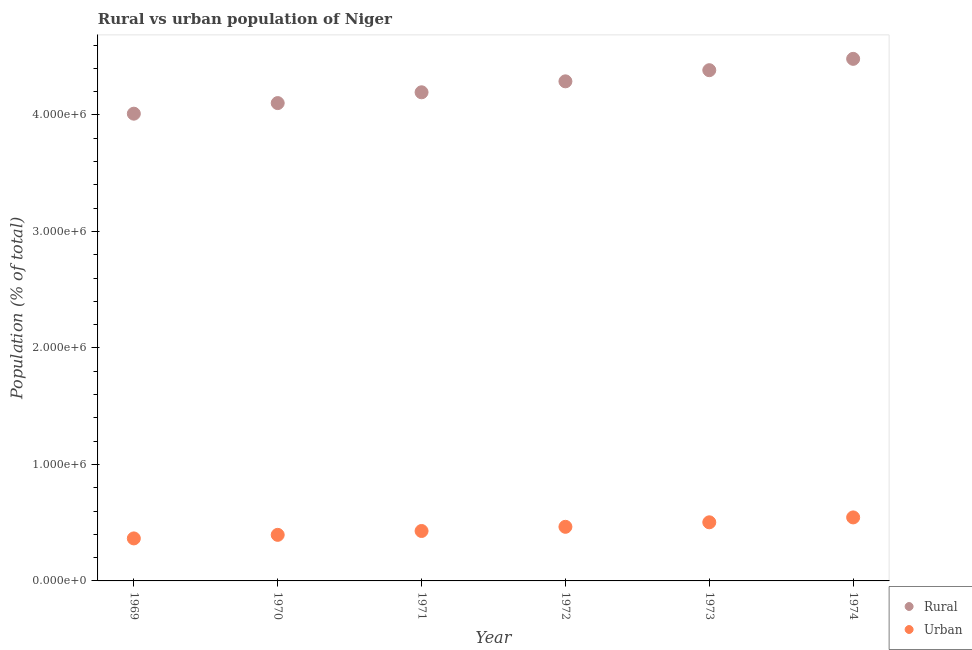What is the rural population density in 1972?
Your response must be concise. 4.29e+06. Across all years, what is the maximum urban population density?
Your response must be concise. 5.45e+05. Across all years, what is the minimum rural population density?
Offer a very short reply. 4.01e+06. In which year was the urban population density maximum?
Provide a succinct answer. 1974. In which year was the urban population density minimum?
Keep it short and to the point. 1969. What is the total rural population density in the graph?
Offer a very short reply. 2.55e+07. What is the difference between the rural population density in 1970 and that in 1972?
Provide a short and direct response. -1.87e+05. What is the difference between the urban population density in 1973 and the rural population density in 1971?
Ensure brevity in your answer.  -3.69e+06. What is the average urban population density per year?
Your response must be concise. 4.50e+05. In the year 1972, what is the difference between the urban population density and rural population density?
Ensure brevity in your answer.  -3.82e+06. What is the ratio of the rural population density in 1971 to that in 1973?
Offer a terse response. 0.96. What is the difference between the highest and the second highest rural population density?
Offer a very short reply. 9.73e+04. What is the difference between the highest and the lowest rural population density?
Give a very brief answer. 4.71e+05. In how many years, is the rural population density greater than the average rural population density taken over all years?
Your answer should be compact. 3. Is the sum of the rural population density in 1969 and 1974 greater than the maximum urban population density across all years?
Provide a short and direct response. Yes. Is the rural population density strictly greater than the urban population density over the years?
Give a very brief answer. Yes. Is the rural population density strictly less than the urban population density over the years?
Ensure brevity in your answer.  No. How many dotlines are there?
Your answer should be compact. 2. Does the graph contain any zero values?
Your answer should be very brief. No. Does the graph contain grids?
Your response must be concise. No. Where does the legend appear in the graph?
Make the answer very short. Bottom right. How many legend labels are there?
Offer a terse response. 2. How are the legend labels stacked?
Offer a terse response. Vertical. What is the title of the graph?
Your answer should be very brief. Rural vs urban population of Niger. Does "Foreign liabilities" appear as one of the legend labels in the graph?
Your response must be concise. No. What is the label or title of the Y-axis?
Keep it short and to the point. Population (% of total). What is the Population (% of total) in Rural in 1969?
Offer a terse response. 4.01e+06. What is the Population (% of total) in Urban in 1969?
Your answer should be very brief. 3.65e+05. What is the Population (% of total) in Rural in 1970?
Your response must be concise. 4.10e+06. What is the Population (% of total) of Urban in 1970?
Your answer should be very brief. 3.95e+05. What is the Population (% of total) of Rural in 1971?
Make the answer very short. 4.19e+06. What is the Population (% of total) in Urban in 1971?
Offer a very short reply. 4.29e+05. What is the Population (% of total) in Rural in 1972?
Your response must be concise. 4.29e+06. What is the Population (% of total) in Urban in 1972?
Your answer should be very brief. 4.64e+05. What is the Population (% of total) of Rural in 1973?
Make the answer very short. 4.38e+06. What is the Population (% of total) of Urban in 1973?
Make the answer very short. 5.03e+05. What is the Population (% of total) in Rural in 1974?
Provide a short and direct response. 4.48e+06. What is the Population (% of total) of Urban in 1974?
Offer a terse response. 5.45e+05. Across all years, what is the maximum Population (% of total) of Rural?
Provide a succinct answer. 4.48e+06. Across all years, what is the maximum Population (% of total) of Urban?
Keep it short and to the point. 5.45e+05. Across all years, what is the minimum Population (% of total) in Rural?
Your answer should be compact. 4.01e+06. Across all years, what is the minimum Population (% of total) of Urban?
Your answer should be very brief. 3.65e+05. What is the total Population (% of total) in Rural in the graph?
Make the answer very short. 2.55e+07. What is the total Population (% of total) in Urban in the graph?
Your answer should be compact. 2.70e+06. What is the difference between the Population (% of total) of Rural in 1969 and that in 1970?
Give a very brief answer. -9.09e+04. What is the difference between the Population (% of total) in Urban in 1969 and that in 1970?
Provide a short and direct response. -3.06e+04. What is the difference between the Population (% of total) in Rural in 1969 and that in 1971?
Keep it short and to the point. -1.84e+05. What is the difference between the Population (% of total) in Urban in 1969 and that in 1971?
Provide a succinct answer. -6.37e+04. What is the difference between the Population (% of total) in Rural in 1969 and that in 1972?
Provide a succinct answer. -2.78e+05. What is the difference between the Population (% of total) in Urban in 1969 and that in 1972?
Provide a succinct answer. -9.96e+04. What is the difference between the Population (% of total) of Rural in 1969 and that in 1973?
Offer a very short reply. -3.73e+05. What is the difference between the Population (% of total) of Urban in 1969 and that in 1973?
Your answer should be compact. -1.38e+05. What is the difference between the Population (% of total) of Rural in 1969 and that in 1974?
Give a very brief answer. -4.71e+05. What is the difference between the Population (% of total) of Urban in 1969 and that in 1974?
Provide a succinct answer. -1.80e+05. What is the difference between the Population (% of total) of Rural in 1970 and that in 1971?
Keep it short and to the point. -9.27e+04. What is the difference between the Population (% of total) of Urban in 1970 and that in 1971?
Provide a short and direct response. -3.31e+04. What is the difference between the Population (% of total) of Rural in 1970 and that in 1972?
Ensure brevity in your answer.  -1.87e+05. What is the difference between the Population (% of total) in Urban in 1970 and that in 1972?
Offer a terse response. -6.90e+04. What is the difference between the Population (% of total) of Rural in 1970 and that in 1973?
Offer a very short reply. -2.82e+05. What is the difference between the Population (% of total) in Urban in 1970 and that in 1973?
Keep it short and to the point. -1.08e+05. What is the difference between the Population (% of total) of Rural in 1970 and that in 1974?
Keep it short and to the point. -3.80e+05. What is the difference between the Population (% of total) in Urban in 1970 and that in 1974?
Your answer should be compact. -1.50e+05. What is the difference between the Population (% of total) in Rural in 1971 and that in 1972?
Your answer should be very brief. -9.41e+04. What is the difference between the Population (% of total) of Urban in 1971 and that in 1972?
Your answer should be very brief. -3.59e+04. What is the difference between the Population (% of total) in Rural in 1971 and that in 1973?
Offer a very short reply. -1.90e+05. What is the difference between the Population (% of total) of Urban in 1971 and that in 1973?
Offer a very short reply. -7.46e+04. What is the difference between the Population (% of total) in Rural in 1971 and that in 1974?
Your response must be concise. -2.87e+05. What is the difference between the Population (% of total) of Urban in 1971 and that in 1974?
Offer a very short reply. -1.17e+05. What is the difference between the Population (% of total) in Rural in 1972 and that in 1973?
Offer a very short reply. -9.57e+04. What is the difference between the Population (% of total) in Urban in 1972 and that in 1973?
Provide a succinct answer. -3.87e+04. What is the difference between the Population (% of total) of Rural in 1972 and that in 1974?
Your answer should be very brief. -1.93e+05. What is the difference between the Population (% of total) in Urban in 1972 and that in 1974?
Your response must be concise. -8.07e+04. What is the difference between the Population (% of total) in Rural in 1973 and that in 1974?
Your answer should be compact. -9.73e+04. What is the difference between the Population (% of total) in Urban in 1973 and that in 1974?
Provide a short and direct response. -4.19e+04. What is the difference between the Population (% of total) of Rural in 1969 and the Population (% of total) of Urban in 1970?
Your answer should be compact. 3.62e+06. What is the difference between the Population (% of total) in Rural in 1969 and the Population (% of total) in Urban in 1971?
Ensure brevity in your answer.  3.58e+06. What is the difference between the Population (% of total) of Rural in 1969 and the Population (% of total) of Urban in 1972?
Your answer should be very brief. 3.55e+06. What is the difference between the Population (% of total) in Rural in 1969 and the Population (% of total) in Urban in 1973?
Ensure brevity in your answer.  3.51e+06. What is the difference between the Population (% of total) of Rural in 1969 and the Population (% of total) of Urban in 1974?
Offer a terse response. 3.47e+06. What is the difference between the Population (% of total) of Rural in 1970 and the Population (% of total) of Urban in 1971?
Offer a very short reply. 3.67e+06. What is the difference between the Population (% of total) in Rural in 1970 and the Population (% of total) in Urban in 1972?
Ensure brevity in your answer.  3.64e+06. What is the difference between the Population (% of total) in Rural in 1970 and the Population (% of total) in Urban in 1973?
Provide a succinct answer. 3.60e+06. What is the difference between the Population (% of total) in Rural in 1970 and the Population (% of total) in Urban in 1974?
Give a very brief answer. 3.56e+06. What is the difference between the Population (% of total) in Rural in 1971 and the Population (% of total) in Urban in 1972?
Ensure brevity in your answer.  3.73e+06. What is the difference between the Population (% of total) in Rural in 1971 and the Population (% of total) in Urban in 1973?
Provide a succinct answer. 3.69e+06. What is the difference between the Population (% of total) of Rural in 1971 and the Population (% of total) of Urban in 1974?
Your answer should be very brief. 3.65e+06. What is the difference between the Population (% of total) of Rural in 1972 and the Population (% of total) of Urban in 1973?
Ensure brevity in your answer.  3.79e+06. What is the difference between the Population (% of total) in Rural in 1972 and the Population (% of total) in Urban in 1974?
Make the answer very short. 3.74e+06. What is the difference between the Population (% of total) of Rural in 1973 and the Population (% of total) of Urban in 1974?
Your answer should be compact. 3.84e+06. What is the average Population (% of total) of Rural per year?
Offer a terse response. 4.24e+06. What is the average Population (% of total) of Urban per year?
Give a very brief answer. 4.50e+05. In the year 1969, what is the difference between the Population (% of total) of Rural and Population (% of total) of Urban?
Your answer should be compact. 3.65e+06. In the year 1970, what is the difference between the Population (% of total) of Rural and Population (% of total) of Urban?
Give a very brief answer. 3.71e+06. In the year 1971, what is the difference between the Population (% of total) in Rural and Population (% of total) in Urban?
Provide a succinct answer. 3.77e+06. In the year 1972, what is the difference between the Population (% of total) in Rural and Population (% of total) in Urban?
Keep it short and to the point. 3.82e+06. In the year 1973, what is the difference between the Population (% of total) in Rural and Population (% of total) in Urban?
Your response must be concise. 3.88e+06. In the year 1974, what is the difference between the Population (% of total) in Rural and Population (% of total) in Urban?
Your answer should be very brief. 3.94e+06. What is the ratio of the Population (% of total) of Rural in 1969 to that in 1970?
Your answer should be very brief. 0.98. What is the ratio of the Population (% of total) in Urban in 1969 to that in 1970?
Provide a short and direct response. 0.92. What is the ratio of the Population (% of total) in Rural in 1969 to that in 1971?
Offer a terse response. 0.96. What is the ratio of the Population (% of total) of Urban in 1969 to that in 1971?
Offer a terse response. 0.85. What is the ratio of the Population (% of total) in Rural in 1969 to that in 1972?
Offer a very short reply. 0.94. What is the ratio of the Population (% of total) of Urban in 1969 to that in 1972?
Make the answer very short. 0.79. What is the ratio of the Population (% of total) of Rural in 1969 to that in 1973?
Offer a terse response. 0.91. What is the ratio of the Population (% of total) of Urban in 1969 to that in 1973?
Offer a very short reply. 0.73. What is the ratio of the Population (% of total) of Rural in 1969 to that in 1974?
Offer a terse response. 0.9. What is the ratio of the Population (% of total) of Urban in 1969 to that in 1974?
Provide a succinct answer. 0.67. What is the ratio of the Population (% of total) in Rural in 1970 to that in 1971?
Make the answer very short. 0.98. What is the ratio of the Population (% of total) in Urban in 1970 to that in 1971?
Offer a terse response. 0.92. What is the ratio of the Population (% of total) in Rural in 1970 to that in 1972?
Give a very brief answer. 0.96. What is the ratio of the Population (% of total) of Urban in 1970 to that in 1972?
Give a very brief answer. 0.85. What is the ratio of the Population (% of total) in Rural in 1970 to that in 1973?
Ensure brevity in your answer.  0.94. What is the ratio of the Population (% of total) of Urban in 1970 to that in 1973?
Ensure brevity in your answer.  0.79. What is the ratio of the Population (% of total) of Rural in 1970 to that in 1974?
Offer a terse response. 0.92. What is the ratio of the Population (% of total) in Urban in 1970 to that in 1974?
Offer a terse response. 0.73. What is the ratio of the Population (% of total) of Rural in 1971 to that in 1972?
Your answer should be compact. 0.98. What is the ratio of the Population (% of total) of Urban in 1971 to that in 1972?
Keep it short and to the point. 0.92. What is the ratio of the Population (% of total) of Rural in 1971 to that in 1973?
Keep it short and to the point. 0.96. What is the ratio of the Population (% of total) of Urban in 1971 to that in 1973?
Your answer should be compact. 0.85. What is the ratio of the Population (% of total) of Rural in 1971 to that in 1974?
Keep it short and to the point. 0.94. What is the ratio of the Population (% of total) of Urban in 1971 to that in 1974?
Your response must be concise. 0.79. What is the ratio of the Population (% of total) in Rural in 1972 to that in 1973?
Ensure brevity in your answer.  0.98. What is the ratio of the Population (% of total) of Urban in 1972 to that in 1973?
Make the answer very short. 0.92. What is the ratio of the Population (% of total) in Rural in 1972 to that in 1974?
Offer a very short reply. 0.96. What is the ratio of the Population (% of total) of Urban in 1972 to that in 1974?
Offer a very short reply. 0.85. What is the ratio of the Population (% of total) of Rural in 1973 to that in 1974?
Offer a very short reply. 0.98. What is the ratio of the Population (% of total) in Urban in 1973 to that in 1974?
Your answer should be compact. 0.92. What is the difference between the highest and the second highest Population (% of total) in Rural?
Provide a short and direct response. 9.73e+04. What is the difference between the highest and the second highest Population (% of total) of Urban?
Provide a short and direct response. 4.19e+04. What is the difference between the highest and the lowest Population (% of total) of Rural?
Offer a terse response. 4.71e+05. What is the difference between the highest and the lowest Population (% of total) in Urban?
Keep it short and to the point. 1.80e+05. 